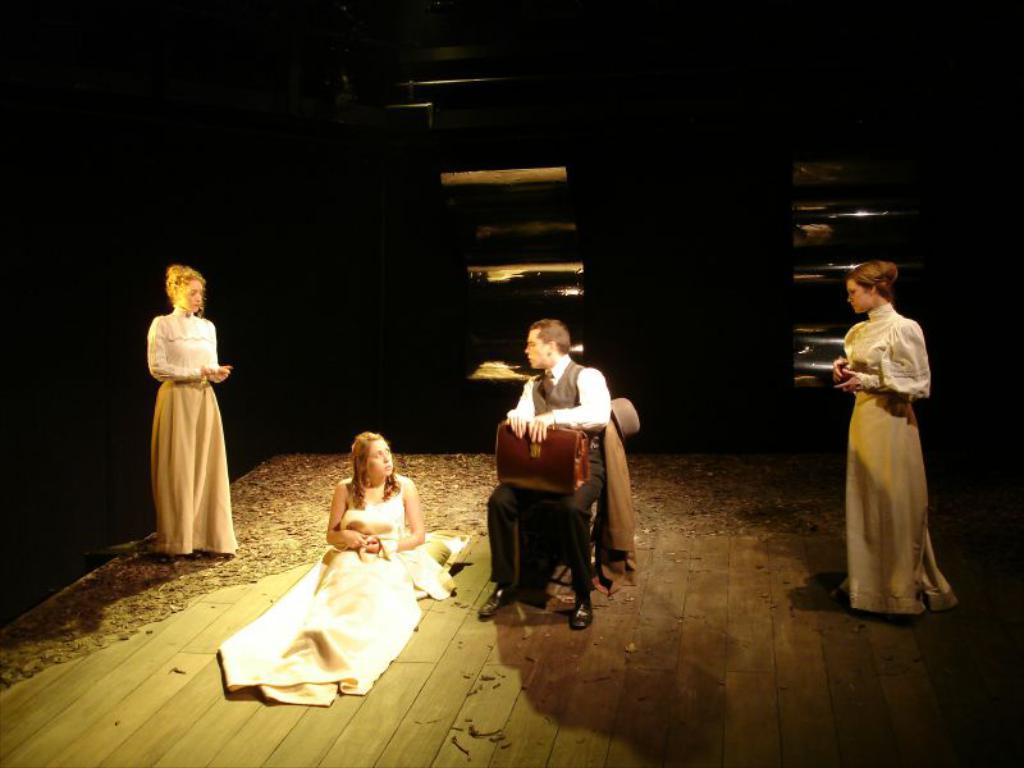How would you summarize this image in a sentence or two? As we can see in the image there are four people. These three women are wearing white color dresses. The person over here is holding a suitcase and sitting on chair. The image is little dark. 